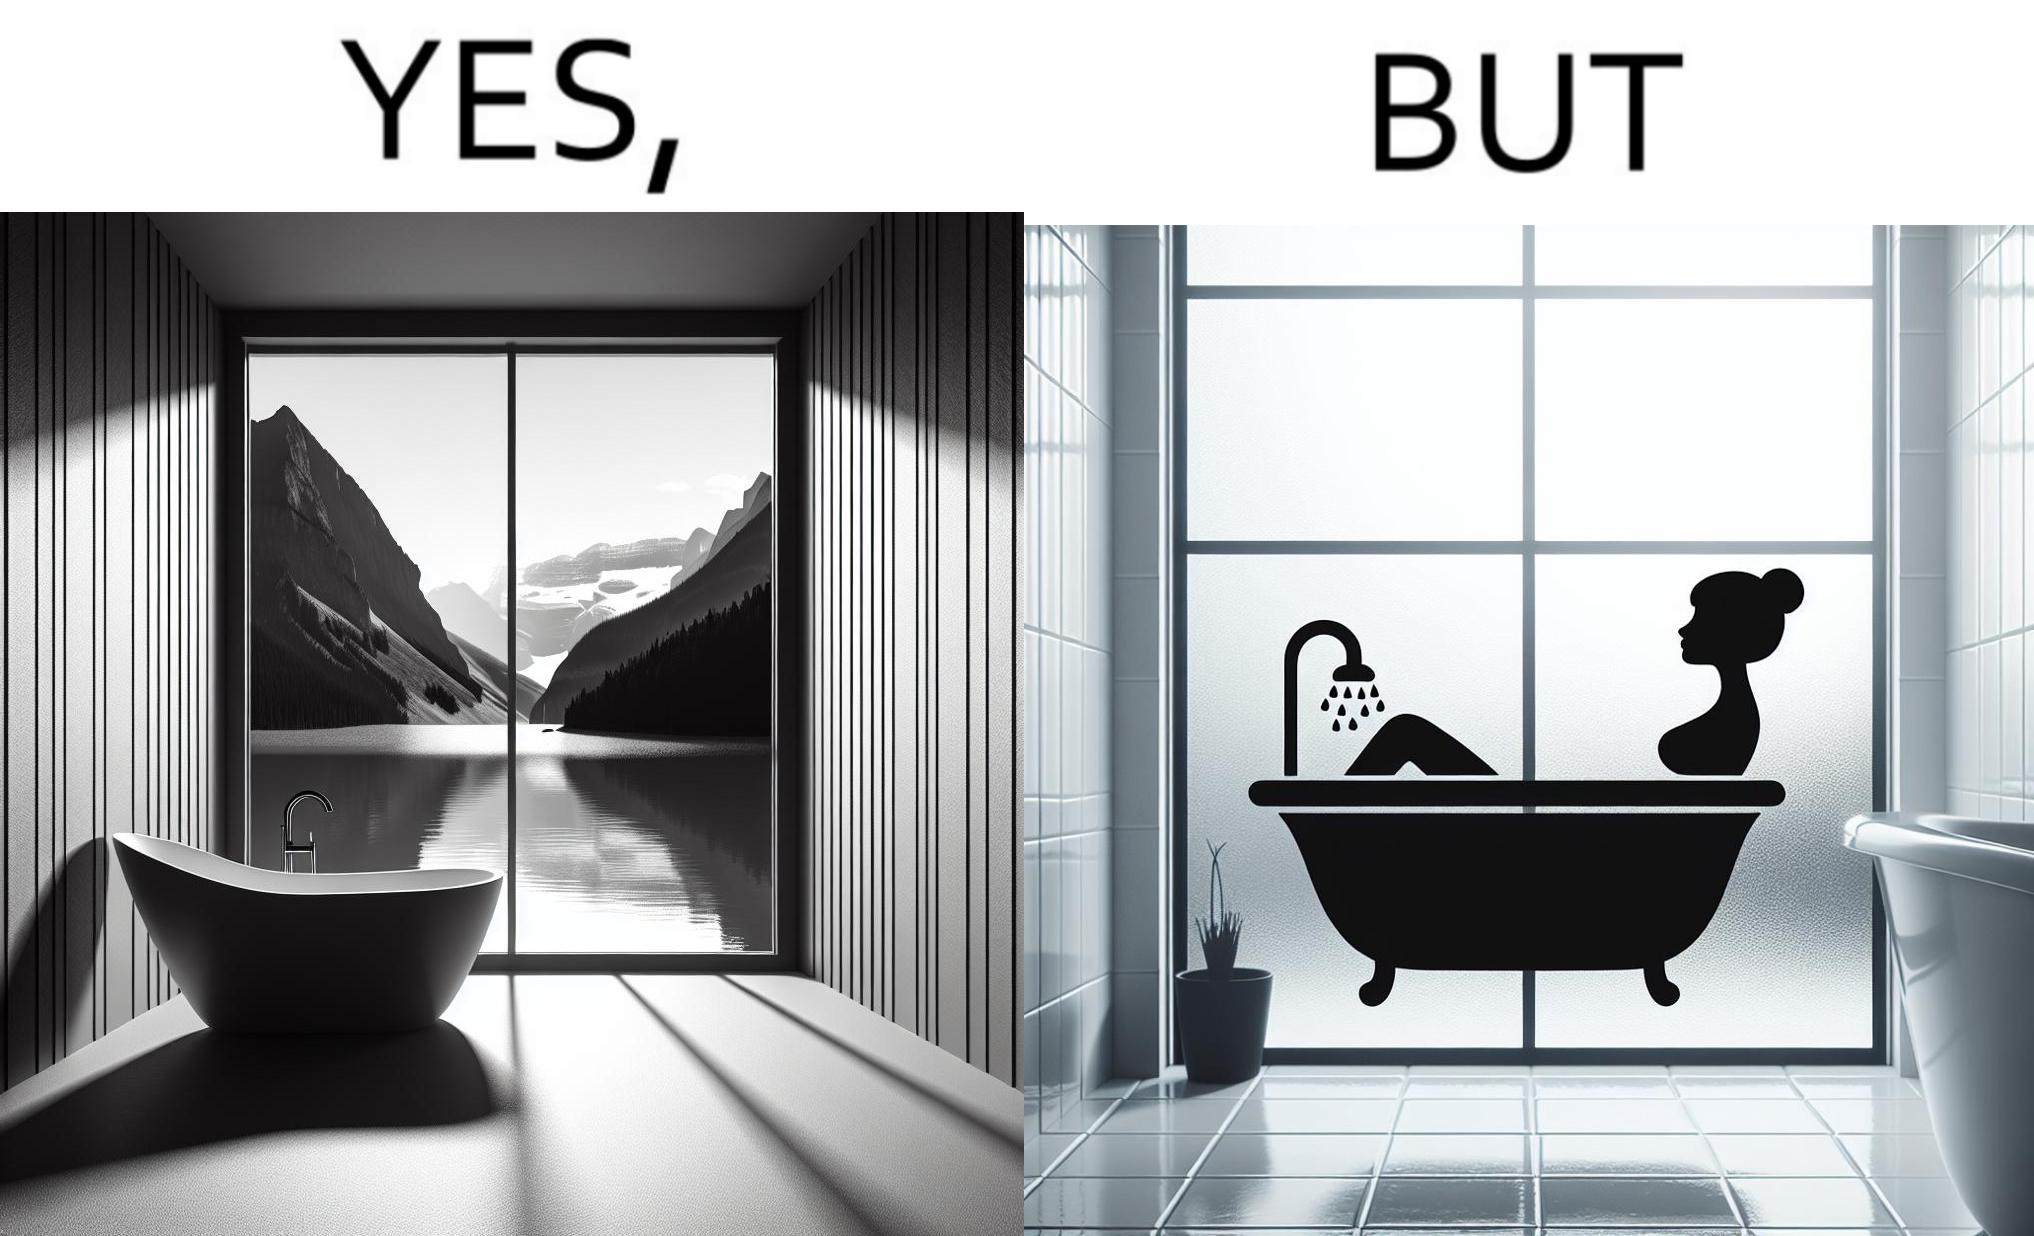What does this image depict? The image is ironical, as a bathtub near a window having a very scenic view, becomes misty when someone is bathing, thus making the scenic view blurry. 